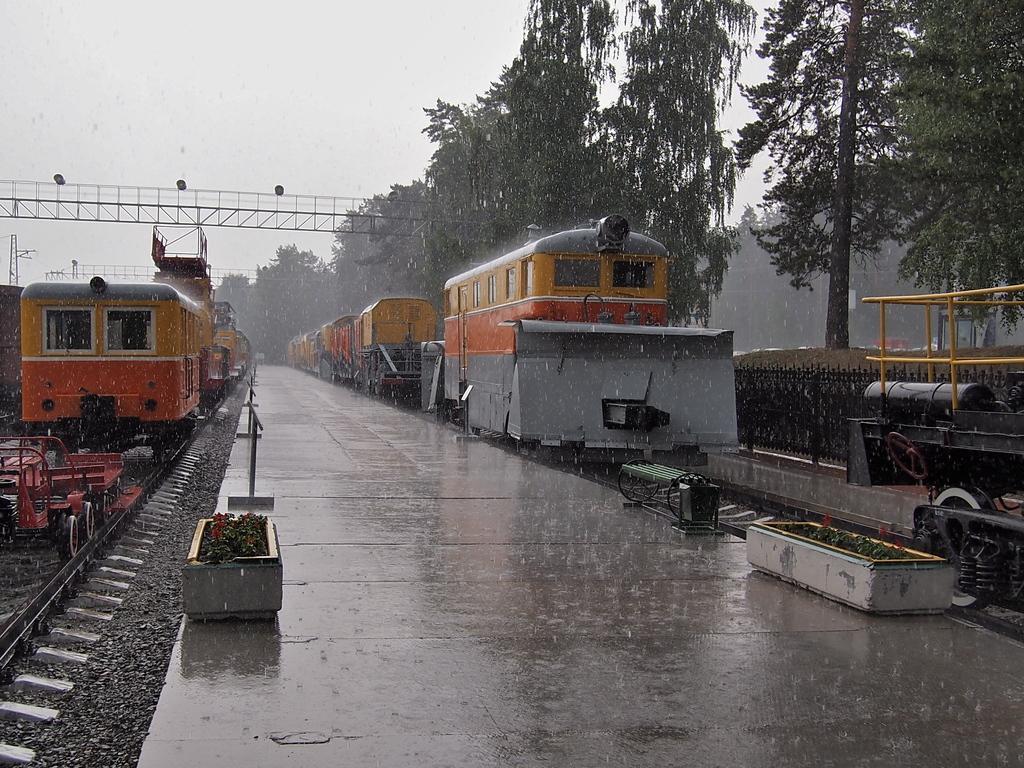Describe this image in one or two sentences. In this picture we can see trains on railway tracks, beside the tracks we can see a platform and some objects and in the background we can see trees, sky. 